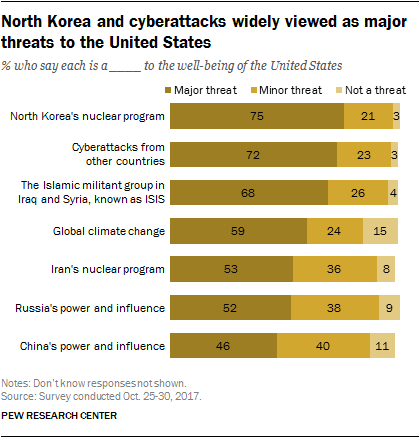Draw attention to some important aspects in this diagram. The second largest bar value in the graph is 72. To determine the median value of each attribute separately, we would need to first calculate the values of each attribute for each individual record in the dataset. Once we have these values, we can sort them in ascending order and find the middle value, which would be the median value for that attribute. We would repeat this process for all three attributes to find the median value for the entire dataset. 